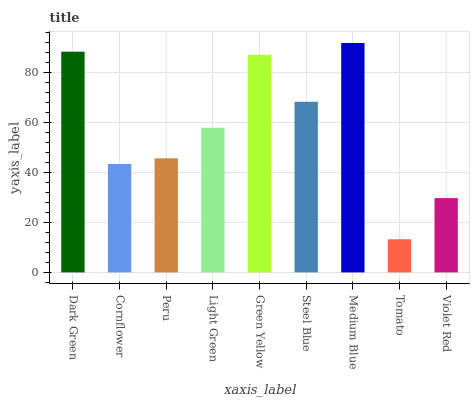Is Tomato the minimum?
Answer yes or no. Yes. Is Medium Blue the maximum?
Answer yes or no. Yes. Is Cornflower the minimum?
Answer yes or no. No. Is Cornflower the maximum?
Answer yes or no. No. Is Dark Green greater than Cornflower?
Answer yes or no. Yes. Is Cornflower less than Dark Green?
Answer yes or no. Yes. Is Cornflower greater than Dark Green?
Answer yes or no. No. Is Dark Green less than Cornflower?
Answer yes or no. No. Is Light Green the high median?
Answer yes or no. Yes. Is Light Green the low median?
Answer yes or no. Yes. Is Steel Blue the high median?
Answer yes or no. No. Is Tomato the low median?
Answer yes or no. No. 